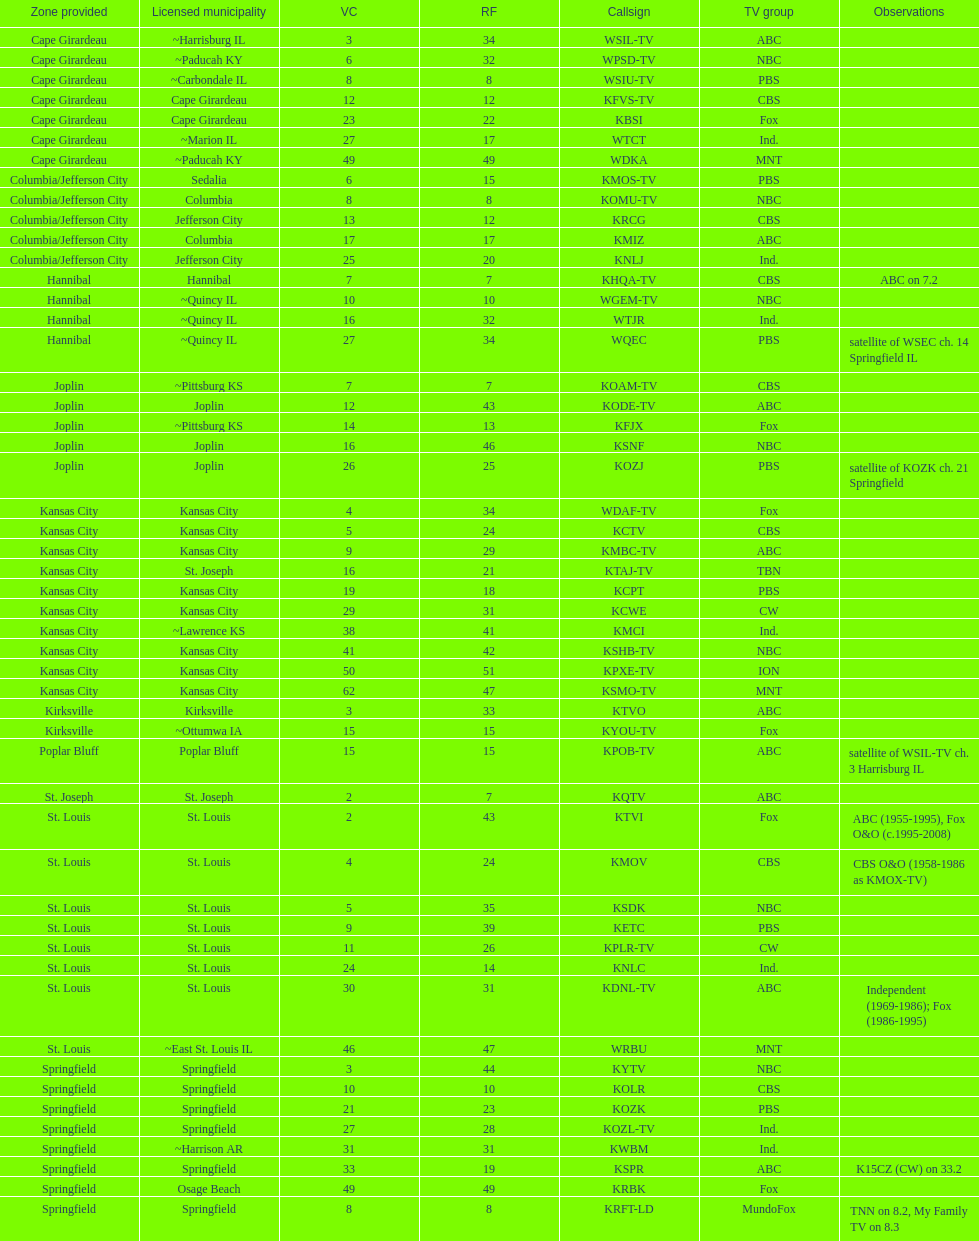How many of these missouri tv stations are actually licensed in a city in illinois (il)? 7. I'm looking to parse the entire table for insights. Could you assist me with that? {'header': ['Zone provided', 'Licensed municipality', 'VC', 'RF', 'Callsign', 'TV group', 'Observations'], 'rows': [['Cape Girardeau', '~Harrisburg IL', '3', '34', 'WSIL-TV', 'ABC', ''], ['Cape Girardeau', '~Paducah KY', '6', '32', 'WPSD-TV', 'NBC', ''], ['Cape Girardeau', '~Carbondale IL', '8', '8', 'WSIU-TV', 'PBS', ''], ['Cape Girardeau', 'Cape Girardeau', '12', '12', 'KFVS-TV', 'CBS', ''], ['Cape Girardeau', 'Cape Girardeau', '23', '22', 'KBSI', 'Fox', ''], ['Cape Girardeau', '~Marion IL', '27', '17', 'WTCT', 'Ind.', ''], ['Cape Girardeau', '~Paducah KY', '49', '49', 'WDKA', 'MNT', ''], ['Columbia/Jefferson City', 'Sedalia', '6', '15', 'KMOS-TV', 'PBS', ''], ['Columbia/Jefferson City', 'Columbia', '8', '8', 'KOMU-TV', 'NBC', ''], ['Columbia/Jefferson City', 'Jefferson City', '13', '12', 'KRCG', 'CBS', ''], ['Columbia/Jefferson City', 'Columbia', '17', '17', 'KMIZ', 'ABC', ''], ['Columbia/Jefferson City', 'Jefferson City', '25', '20', 'KNLJ', 'Ind.', ''], ['Hannibal', 'Hannibal', '7', '7', 'KHQA-TV', 'CBS', 'ABC on 7.2'], ['Hannibal', '~Quincy IL', '10', '10', 'WGEM-TV', 'NBC', ''], ['Hannibal', '~Quincy IL', '16', '32', 'WTJR', 'Ind.', ''], ['Hannibal', '~Quincy IL', '27', '34', 'WQEC', 'PBS', 'satellite of WSEC ch. 14 Springfield IL'], ['Joplin', '~Pittsburg KS', '7', '7', 'KOAM-TV', 'CBS', ''], ['Joplin', 'Joplin', '12', '43', 'KODE-TV', 'ABC', ''], ['Joplin', '~Pittsburg KS', '14', '13', 'KFJX', 'Fox', ''], ['Joplin', 'Joplin', '16', '46', 'KSNF', 'NBC', ''], ['Joplin', 'Joplin', '26', '25', 'KOZJ', 'PBS', 'satellite of KOZK ch. 21 Springfield'], ['Kansas City', 'Kansas City', '4', '34', 'WDAF-TV', 'Fox', ''], ['Kansas City', 'Kansas City', '5', '24', 'KCTV', 'CBS', ''], ['Kansas City', 'Kansas City', '9', '29', 'KMBC-TV', 'ABC', ''], ['Kansas City', 'St. Joseph', '16', '21', 'KTAJ-TV', 'TBN', ''], ['Kansas City', 'Kansas City', '19', '18', 'KCPT', 'PBS', ''], ['Kansas City', 'Kansas City', '29', '31', 'KCWE', 'CW', ''], ['Kansas City', '~Lawrence KS', '38', '41', 'KMCI', 'Ind.', ''], ['Kansas City', 'Kansas City', '41', '42', 'KSHB-TV', 'NBC', ''], ['Kansas City', 'Kansas City', '50', '51', 'KPXE-TV', 'ION', ''], ['Kansas City', 'Kansas City', '62', '47', 'KSMO-TV', 'MNT', ''], ['Kirksville', 'Kirksville', '3', '33', 'KTVO', 'ABC', ''], ['Kirksville', '~Ottumwa IA', '15', '15', 'KYOU-TV', 'Fox', ''], ['Poplar Bluff', 'Poplar Bluff', '15', '15', 'KPOB-TV', 'ABC', 'satellite of WSIL-TV ch. 3 Harrisburg IL'], ['St. Joseph', 'St. Joseph', '2', '7', 'KQTV', 'ABC', ''], ['St. Louis', 'St. Louis', '2', '43', 'KTVI', 'Fox', 'ABC (1955-1995), Fox O&O (c.1995-2008)'], ['St. Louis', 'St. Louis', '4', '24', 'KMOV', 'CBS', 'CBS O&O (1958-1986 as KMOX-TV)'], ['St. Louis', 'St. Louis', '5', '35', 'KSDK', 'NBC', ''], ['St. Louis', 'St. Louis', '9', '39', 'KETC', 'PBS', ''], ['St. Louis', 'St. Louis', '11', '26', 'KPLR-TV', 'CW', ''], ['St. Louis', 'St. Louis', '24', '14', 'KNLC', 'Ind.', ''], ['St. Louis', 'St. Louis', '30', '31', 'KDNL-TV', 'ABC', 'Independent (1969-1986); Fox (1986-1995)'], ['St. Louis', '~East St. Louis IL', '46', '47', 'WRBU', 'MNT', ''], ['Springfield', 'Springfield', '3', '44', 'KYTV', 'NBC', ''], ['Springfield', 'Springfield', '10', '10', 'KOLR', 'CBS', ''], ['Springfield', 'Springfield', '21', '23', 'KOZK', 'PBS', ''], ['Springfield', 'Springfield', '27', '28', 'KOZL-TV', 'Ind.', ''], ['Springfield', '~Harrison AR', '31', '31', 'KWBM', 'Ind.', ''], ['Springfield', 'Springfield', '33', '19', 'KSPR', 'ABC', 'K15CZ (CW) on 33.2'], ['Springfield', 'Osage Beach', '49', '49', 'KRBK', 'Fox', ''], ['Springfield', 'Springfield', '8', '8', 'KRFT-LD', 'MundoFox', 'TNN on 8.2, My Family TV on 8.3']]} 